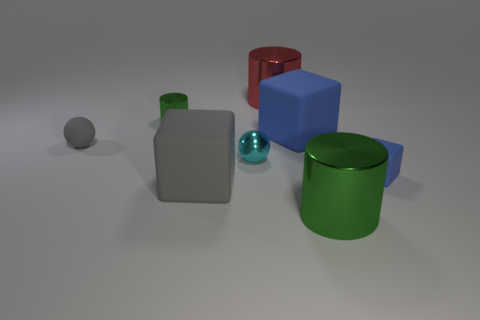There is a large metal object that is the same color as the tiny metal cylinder; what shape is it?
Offer a very short reply. Cylinder. Are there any other things that are the same color as the tiny cylinder?
Offer a very short reply. Yes. Are there any blue blocks in front of the matte ball?
Keep it short and to the point. Yes. Do the tiny cyan thing and the gray rubber object that is behind the tiny metal sphere have the same shape?
Offer a very short reply. Yes. The tiny rubber thing in front of the cyan thing right of the tiny sphere behind the cyan thing is what color?
Your response must be concise. Blue. What is the shape of the object that is to the left of the shiny cylinder that is left of the small cyan shiny sphere?
Offer a terse response. Sphere. Is the number of large metal things behind the tiny gray ball greater than the number of large brown shiny cubes?
Provide a succinct answer. Yes. Does the green object left of the red shiny cylinder have the same shape as the small cyan metal thing?
Your answer should be compact. No. Is there a green shiny thing that has the same shape as the tiny cyan thing?
Make the answer very short. No. What number of objects are large rubber things behind the tiny cyan sphere or large blue objects?
Keep it short and to the point. 1. 